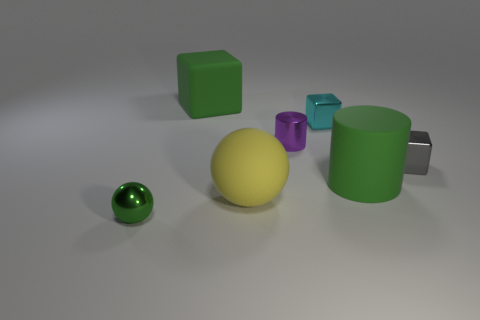Subtract all small cyan shiny blocks. How many blocks are left? 2 Add 1 large cyan cylinders. How many objects exist? 8 Subtract 2 blocks. How many blocks are left? 1 Subtract all cyan cubes. How many cubes are left? 2 Subtract all red blocks. Subtract all purple cylinders. How many blocks are left? 3 Subtract all blue cylinders. Subtract all tiny blocks. How many objects are left? 5 Add 5 green rubber blocks. How many green rubber blocks are left? 6 Add 6 tiny shiny cubes. How many tiny shiny cubes exist? 8 Subtract 0 blue cylinders. How many objects are left? 7 Subtract all cylinders. How many objects are left? 5 